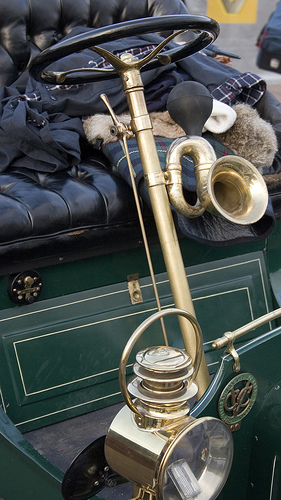<image>
Is there a horn on the seat? No. The horn is not positioned on the seat. They may be near each other, but the horn is not supported by or resting on top of the seat. 